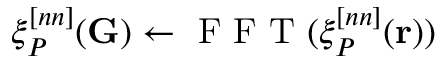Convert formula to latex. <formula><loc_0><loc_0><loc_500><loc_500>\xi _ { P } ^ { [ n n ] } ( G ) \leftarrow F F T ( \xi _ { P } ^ { [ n n ] } ( r ) )</formula> 